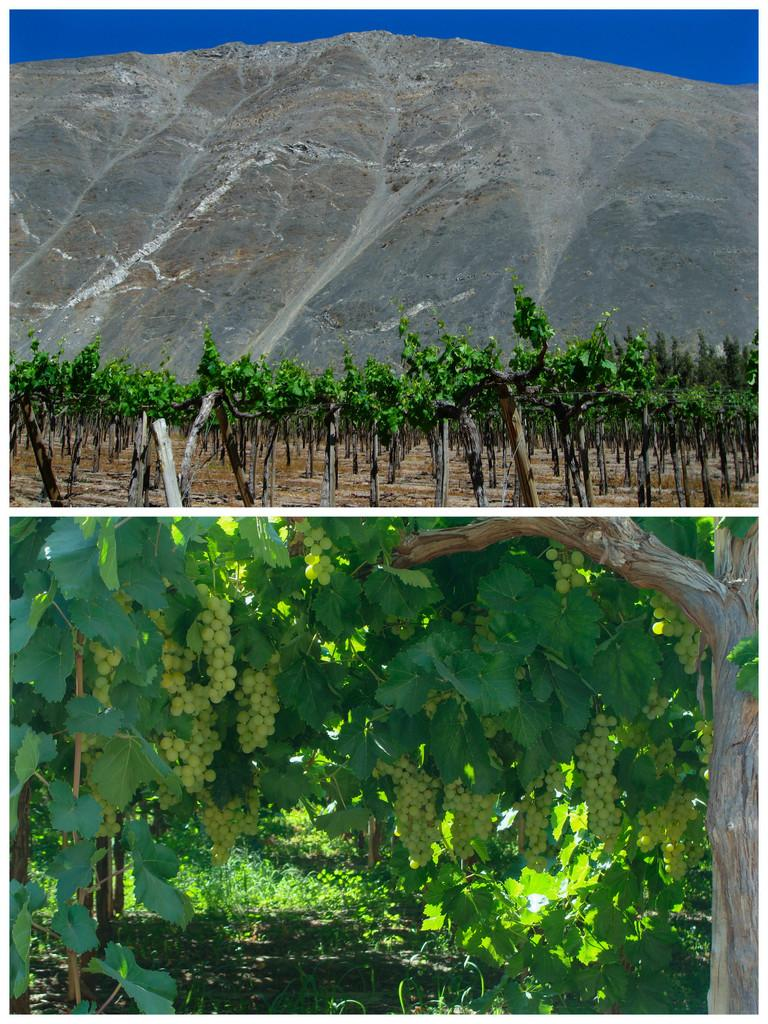What type of artwork is shown in the image? The image is a collage of pictures. What natural elements can be seen in the collage? There are trees depicted in the collage. What edible items are featured in the collage? There are fruits depicted in the collage. What type of rock is being processed in the image? There is no rock or process depicted in the image; it is a collage of pictures featuring trees and fruits. 